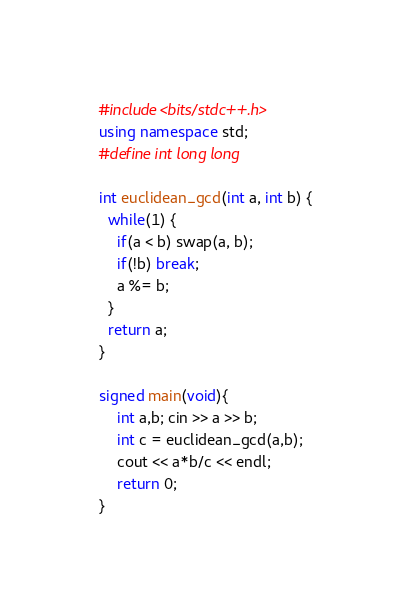<code> <loc_0><loc_0><loc_500><loc_500><_C++_>#include<bits/stdc++.h>
using namespace std;
#define int long long

int euclidean_gcd(int a, int b) {
  while(1) {
    if(a < b) swap(a, b);
    if(!b) break;
    a %= b;
  }
  return a;
}

signed main(void){
    int a,b; cin >> a >> b;
    int c = euclidean_gcd(a,b);
    cout << a*b/c << endl;
    return 0;
}</code> 